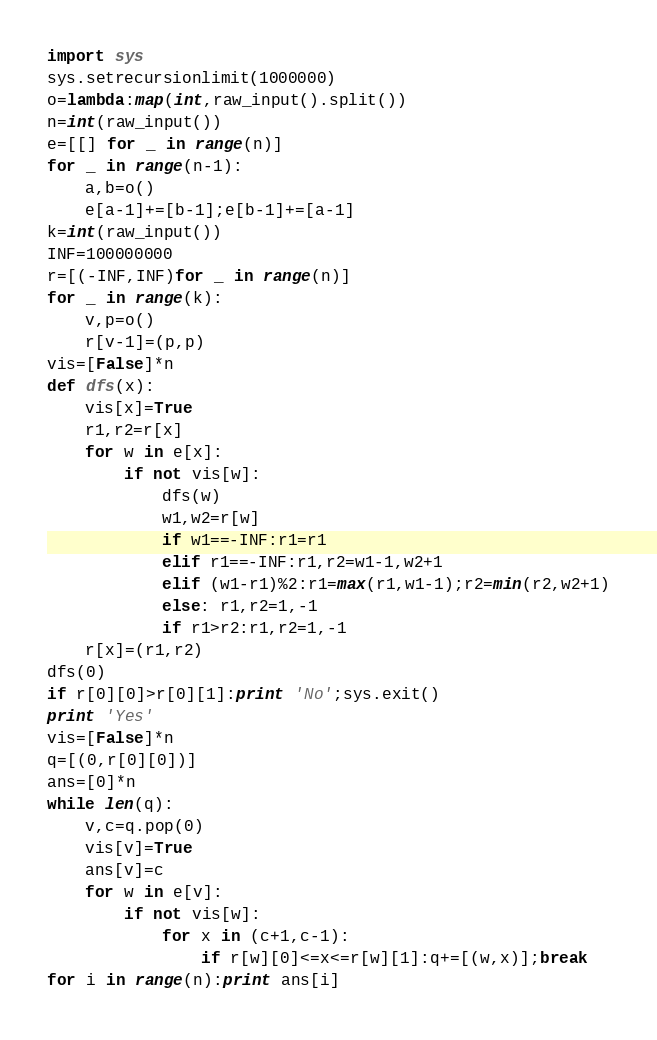<code> <loc_0><loc_0><loc_500><loc_500><_Python_>import sys
sys.setrecursionlimit(1000000)
o=lambda:map(int,raw_input().split())
n=int(raw_input())
e=[[] for _ in range(n)]
for _ in range(n-1):
    a,b=o()
    e[a-1]+=[b-1];e[b-1]+=[a-1]
k=int(raw_input())
INF=100000000
r=[(-INF,INF)for _ in range(n)]
for _ in range(k):
    v,p=o()
    r[v-1]=(p,p)
vis=[False]*n
def dfs(x):
    vis[x]=True
    r1,r2=r[x]
    for w in e[x]:
        if not vis[w]:
            dfs(w)
            w1,w2=r[w]
            if w1==-INF:r1=r1
            elif r1==-INF:r1,r2=w1-1,w2+1
            elif (w1-r1)%2:r1=max(r1,w1-1);r2=min(r2,w2+1)
            else: r1,r2=1,-1
            if r1>r2:r1,r2=1,-1
    r[x]=(r1,r2)
dfs(0)
if r[0][0]>r[0][1]:print 'No';sys.exit()
print 'Yes'
vis=[False]*n
q=[(0,r[0][0])]
ans=[0]*n
while len(q):
    v,c=q.pop(0)
    vis[v]=True
    ans[v]=c
    for w in e[v]:
        if not vis[w]:
            for x in (c+1,c-1):
                if r[w][0]<=x<=r[w][1]:q+=[(w,x)];break
for i in range(n):print ans[i]
</code> 